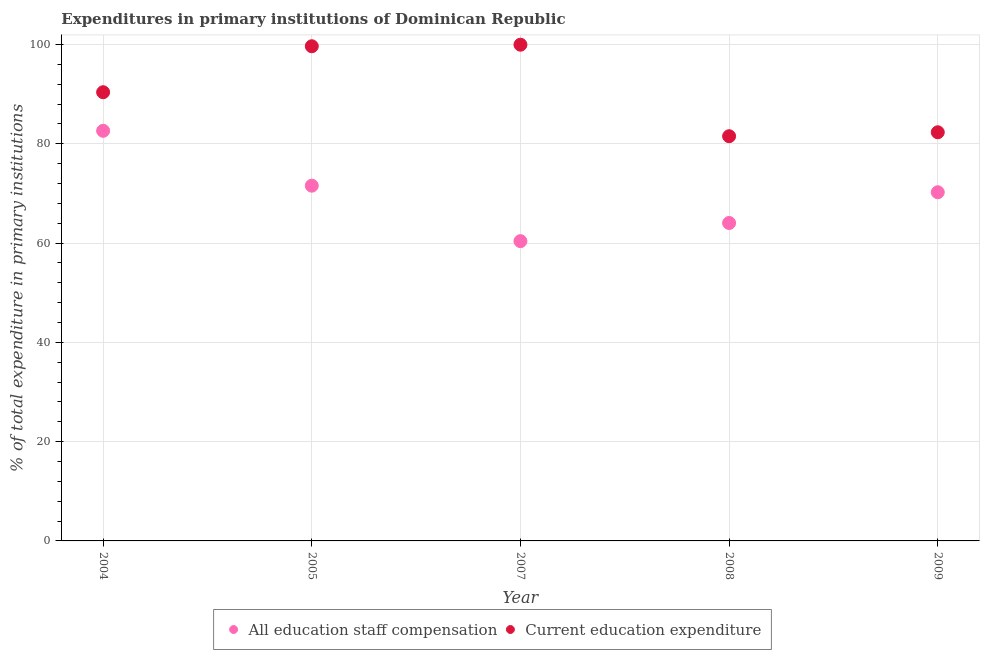How many different coloured dotlines are there?
Your response must be concise. 2. Is the number of dotlines equal to the number of legend labels?
Give a very brief answer. Yes. What is the expenditure in staff compensation in 2009?
Offer a terse response. 70.25. Across all years, what is the maximum expenditure in education?
Make the answer very short. 99.98. Across all years, what is the minimum expenditure in staff compensation?
Your answer should be compact. 60.4. In which year was the expenditure in staff compensation minimum?
Ensure brevity in your answer.  2007. What is the total expenditure in education in the graph?
Ensure brevity in your answer.  453.91. What is the difference between the expenditure in staff compensation in 2005 and that in 2009?
Keep it short and to the point. 1.32. What is the difference between the expenditure in education in 2005 and the expenditure in staff compensation in 2004?
Make the answer very short. 17.04. What is the average expenditure in education per year?
Provide a short and direct response. 90.78. In the year 2009, what is the difference between the expenditure in staff compensation and expenditure in education?
Make the answer very short. -12.08. What is the ratio of the expenditure in staff compensation in 2004 to that in 2009?
Keep it short and to the point. 1.18. Is the expenditure in staff compensation in 2004 less than that in 2005?
Ensure brevity in your answer.  No. Is the difference between the expenditure in staff compensation in 2008 and 2009 greater than the difference between the expenditure in education in 2008 and 2009?
Make the answer very short. No. What is the difference between the highest and the second highest expenditure in staff compensation?
Provide a short and direct response. 11.06. What is the difference between the highest and the lowest expenditure in education?
Keep it short and to the point. 18.44. Is the sum of the expenditure in education in 2005 and 2007 greater than the maximum expenditure in staff compensation across all years?
Make the answer very short. Yes. Is the expenditure in education strictly greater than the expenditure in staff compensation over the years?
Provide a short and direct response. Yes. How many years are there in the graph?
Your answer should be compact. 5. What is the difference between two consecutive major ticks on the Y-axis?
Give a very brief answer. 20. Does the graph contain grids?
Your answer should be very brief. Yes. Where does the legend appear in the graph?
Your answer should be very brief. Bottom center. How many legend labels are there?
Offer a terse response. 2. What is the title of the graph?
Provide a short and direct response. Expenditures in primary institutions of Dominican Republic. Does "Female labor force" appear as one of the legend labels in the graph?
Keep it short and to the point. No. What is the label or title of the Y-axis?
Your answer should be very brief. % of total expenditure in primary institutions. What is the % of total expenditure in primary institutions of All education staff compensation in 2004?
Ensure brevity in your answer.  82.63. What is the % of total expenditure in primary institutions in Current education expenditure in 2004?
Keep it short and to the point. 90.4. What is the % of total expenditure in primary institutions in All education staff compensation in 2005?
Provide a short and direct response. 71.57. What is the % of total expenditure in primary institutions of Current education expenditure in 2005?
Your answer should be compact. 99.66. What is the % of total expenditure in primary institutions in All education staff compensation in 2007?
Provide a short and direct response. 60.4. What is the % of total expenditure in primary institutions of Current education expenditure in 2007?
Give a very brief answer. 99.98. What is the % of total expenditure in primary institutions of All education staff compensation in 2008?
Your answer should be very brief. 64.06. What is the % of total expenditure in primary institutions in Current education expenditure in 2008?
Provide a short and direct response. 81.54. What is the % of total expenditure in primary institutions in All education staff compensation in 2009?
Provide a succinct answer. 70.25. What is the % of total expenditure in primary institutions in Current education expenditure in 2009?
Provide a short and direct response. 82.33. Across all years, what is the maximum % of total expenditure in primary institutions of All education staff compensation?
Your answer should be very brief. 82.63. Across all years, what is the maximum % of total expenditure in primary institutions in Current education expenditure?
Your response must be concise. 99.98. Across all years, what is the minimum % of total expenditure in primary institutions of All education staff compensation?
Your response must be concise. 60.4. Across all years, what is the minimum % of total expenditure in primary institutions of Current education expenditure?
Provide a succinct answer. 81.54. What is the total % of total expenditure in primary institutions of All education staff compensation in the graph?
Your answer should be very brief. 348.9. What is the total % of total expenditure in primary institutions of Current education expenditure in the graph?
Give a very brief answer. 453.91. What is the difference between the % of total expenditure in primary institutions in All education staff compensation in 2004 and that in 2005?
Your response must be concise. 11.06. What is the difference between the % of total expenditure in primary institutions of Current education expenditure in 2004 and that in 2005?
Your answer should be very brief. -9.26. What is the difference between the % of total expenditure in primary institutions of All education staff compensation in 2004 and that in 2007?
Offer a terse response. 22.23. What is the difference between the % of total expenditure in primary institutions in Current education expenditure in 2004 and that in 2007?
Keep it short and to the point. -9.58. What is the difference between the % of total expenditure in primary institutions in All education staff compensation in 2004 and that in 2008?
Your answer should be compact. 18.57. What is the difference between the % of total expenditure in primary institutions of Current education expenditure in 2004 and that in 2008?
Your response must be concise. 8.86. What is the difference between the % of total expenditure in primary institutions in All education staff compensation in 2004 and that in 2009?
Make the answer very short. 12.38. What is the difference between the % of total expenditure in primary institutions in Current education expenditure in 2004 and that in 2009?
Your answer should be compact. 8.07. What is the difference between the % of total expenditure in primary institutions in All education staff compensation in 2005 and that in 2007?
Provide a short and direct response. 11.18. What is the difference between the % of total expenditure in primary institutions in Current education expenditure in 2005 and that in 2007?
Your answer should be very brief. -0.31. What is the difference between the % of total expenditure in primary institutions of All education staff compensation in 2005 and that in 2008?
Offer a terse response. 7.52. What is the difference between the % of total expenditure in primary institutions of Current education expenditure in 2005 and that in 2008?
Your response must be concise. 18.13. What is the difference between the % of total expenditure in primary institutions of All education staff compensation in 2005 and that in 2009?
Your response must be concise. 1.32. What is the difference between the % of total expenditure in primary institutions of Current education expenditure in 2005 and that in 2009?
Ensure brevity in your answer.  17.33. What is the difference between the % of total expenditure in primary institutions of All education staff compensation in 2007 and that in 2008?
Ensure brevity in your answer.  -3.66. What is the difference between the % of total expenditure in primary institutions in Current education expenditure in 2007 and that in 2008?
Keep it short and to the point. 18.44. What is the difference between the % of total expenditure in primary institutions of All education staff compensation in 2007 and that in 2009?
Keep it short and to the point. -9.85. What is the difference between the % of total expenditure in primary institutions of Current education expenditure in 2007 and that in 2009?
Offer a terse response. 17.64. What is the difference between the % of total expenditure in primary institutions of All education staff compensation in 2008 and that in 2009?
Offer a terse response. -6.19. What is the difference between the % of total expenditure in primary institutions of Current education expenditure in 2008 and that in 2009?
Make the answer very short. -0.8. What is the difference between the % of total expenditure in primary institutions in All education staff compensation in 2004 and the % of total expenditure in primary institutions in Current education expenditure in 2005?
Your answer should be compact. -17.04. What is the difference between the % of total expenditure in primary institutions of All education staff compensation in 2004 and the % of total expenditure in primary institutions of Current education expenditure in 2007?
Keep it short and to the point. -17.35. What is the difference between the % of total expenditure in primary institutions in All education staff compensation in 2004 and the % of total expenditure in primary institutions in Current education expenditure in 2008?
Offer a terse response. 1.09. What is the difference between the % of total expenditure in primary institutions of All education staff compensation in 2004 and the % of total expenditure in primary institutions of Current education expenditure in 2009?
Keep it short and to the point. 0.3. What is the difference between the % of total expenditure in primary institutions of All education staff compensation in 2005 and the % of total expenditure in primary institutions of Current education expenditure in 2007?
Keep it short and to the point. -28.4. What is the difference between the % of total expenditure in primary institutions in All education staff compensation in 2005 and the % of total expenditure in primary institutions in Current education expenditure in 2008?
Your answer should be compact. -9.96. What is the difference between the % of total expenditure in primary institutions of All education staff compensation in 2005 and the % of total expenditure in primary institutions of Current education expenditure in 2009?
Offer a terse response. -10.76. What is the difference between the % of total expenditure in primary institutions of All education staff compensation in 2007 and the % of total expenditure in primary institutions of Current education expenditure in 2008?
Your response must be concise. -21.14. What is the difference between the % of total expenditure in primary institutions in All education staff compensation in 2007 and the % of total expenditure in primary institutions in Current education expenditure in 2009?
Give a very brief answer. -21.94. What is the difference between the % of total expenditure in primary institutions of All education staff compensation in 2008 and the % of total expenditure in primary institutions of Current education expenditure in 2009?
Your answer should be very brief. -18.28. What is the average % of total expenditure in primary institutions of All education staff compensation per year?
Make the answer very short. 69.78. What is the average % of total expenditure in primary institutions in Current education expenditure per year?
Ensure brevity in your answer.  90.78. In the year 2004, what is the difference between the % of total expenditure in primary institutions in All education staff compensation and % of total expenditure in primary institutions in Current education expenditure?
Your response must be concise. -7.77. In the year 2005, what is the difference between the % of total expenditure in primary institutions of All education staff compensation and % of total expenditure in primary institutions of Current education expenditure?
Offer a terse response. -28.09. In the year 2007, what is the difference between the % of total expenditure in primary institutions of All education staff compensation and % of total expenditure in primary institutions of Current education expenditure?
Your answer should be very brief. -39.58. In the year 2008, what is the difference between the % of total expenditure in primary institutions in All education staff compensation and % of total expenditure in primary institutions in Current education expenditure?
Make the answer very short. -17.48. In the year 2009, what is the difference between the % of total expenditure in primary institutions in All education staff compensation and % of total expenditure in primary institutions in Current education expenditure?
Your response must be concise. -12.08. What is the ratio of the % of total expenditure in primary institutions in All education staff compensation in 2004 to that in 2005?
Provide a short and direct response. 1.15. What is the ratio of the % of total expenditure in primary institutions of Current education expenditure in 2004 to that in 2005?
Keep it short and to the point. 0.91. What is the ratio of the % of total expenditure in primary institutions in All education staff compensation in 2004 to that in 2007?
Give a very brief answer. 1.37. What is the ratio of the % of total expenditure in primary institutions in Current education expenditure in 2004 to that in 2007?
Offer a very short reply. 0.9. What is the ratio of the % of total expenditure in primary institutions of All education staff compensation in 2004 to that in 2008?
Provide a succinct answer. 1.29. What is the ratio of the % of total expenditure in primary institutions in Current education expenditure in 2004 to that in 2008?
Offer a very short reply. 1.11. What is the ratio of the % of total expenditure in primary institutions in All education staff compensation in 2004 to that in 2009?
Offer a terse response. 1.18. What is the ratio of the % of total expenditure in primary institutions in Current education expenditure in 2004 to that in 2009?
Your answer should be very brief. 1.1. What is the ratio of the % of total expenditure in primary institutions of All education staff compensation in 2005 to that in 2007?
Provide a short and direct response. 1.19. What is the ratio of the % of total expenditure in primary institutions of All education staff compensation in 2005 to that in 2008?
Keep it short and to the point. 1.12. What is the ratio of the % of total expenditure in primary institutions of Current education expenditure in 2005 to that in 2008?
Offer a very short reply. 1.22. What is the ratio of the % of total expenditure in primary institutions in All education staff compensation in 2005 to that in 2009?
Provide a short and direct response. 1.02. What is the ratio of the % of total expenditure in primary institutions in Current education expenditure in 2005 to that in 2009?
Your response must be concise. 1.21. What is the ratio of the % of total expenditure in primary institutions in All education staff compensation in 2007 to that in 2008?
Offer a very short reply. 0.94. What is the ratio of the % of total expenditure in primary institutions of Current education expenditure in 2007 to that in 2008?
Make the answer very short. 1.23. What is the ratio of the % of total expenditure in primary institutions in All education staff compensation in 2007 to that in 2009?
Offer a very short reply. 0.86. What is the ratio of the % of total expenditure in primary institutions in Current education expenditure in 2007 to that in 2009?
Keep it short and to the point. 1.21. What is the ratio of the % of total expenditure in primary institutions of All education staff compensation in 2008 to that in 2009?
Your response must be concise. 0.91. What is the ratio of the % of total expenditure in primary institutions in Current education expenditure in 2008 to that in 2009?
Give a very brief answer. 0.99. What is the difference between the highest and the second highest % of total expenditure in primary institutions of All education staff compensation?
Your answer should be very brief. 11.06. What is the difference between the highest and the second highest % of total expenditure in primary institutions in Current education expenditure?
Keep it short and to the point. 0.31. What is the difference between the highest and the lowest % of total expenditure in primary institutions in All education staff compensation?
Make the answer very short. 22.23. What is the difference between the highest and the lowest % of total expenditure in primary institutions of Current education expenditure?
Keep it short and to the point. 18.44. 